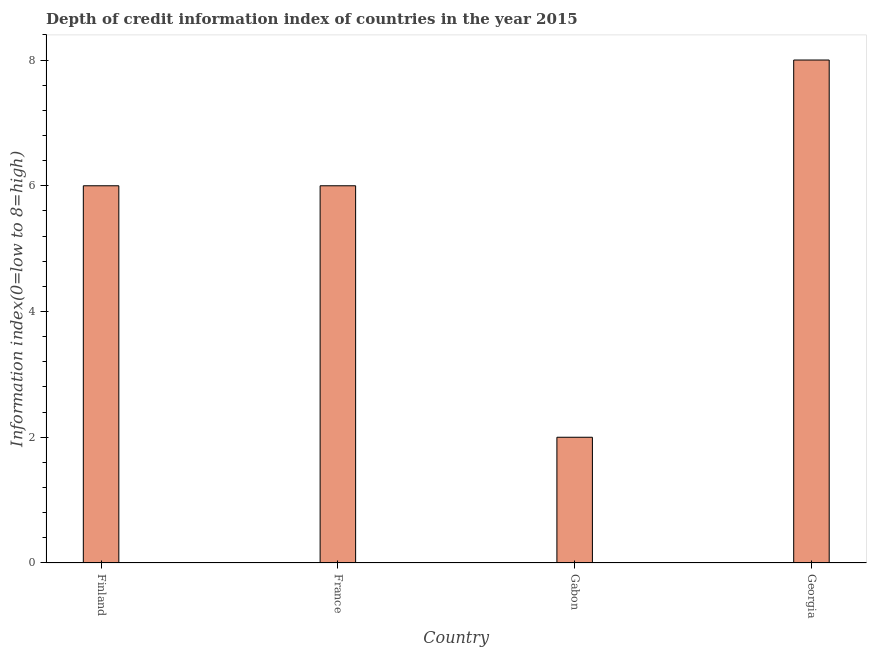Does the graph contain any zero values?
Make the answer very short. No. Does the graph contain grids?
Your answer should be very brief. No. What is the title of the graph?
Keep it short and to the point. Depth of credit information index of countries in the year 2015. What is the label or title of the Y-axis?
Make the answer very short. Information index(0=low to 8=high). What is the depth of credit information index in Finland?
Provide a succinct answer. 6. Across all countries, what is the maximum depth of credit information index?
Your answer should be compact. 8. Across all countries, what is the minimum depth of credit information index?
Ensure brevity in your answer.  2. In which country was the depth of credit information index maximum?
Keep it short and to the point. Georgia. In which country was the depth of credit information index minimum?
Provide a short and direct response. Gabon. What is the sum of the depth of credit information index?
Make the answer very short. 22. What is the average depth of credit information index per country?
Your response must be concise. 5.5. What is the median depth of credit information index?
Your response must be concise. 6. In how many countries, is the depth of credit information index greater than 3.2 ?
Keep it short and to the point. 3. What is the ratio of the depth of credit information index in France to that in Gabon?
Make the answer very short. 3. Is the depth of credit information index in Finland less than that in France?
Offer a terse response. No. Is the sum of the depth of credit information index in Finland and Gabon greater than the maximum depth of credit information index across all countries?
Your answer should be compact. No. In how many countries, is the depth of credit information index greater than the average depth of credit information index taken over all countries?
Offer a very short reply. 3. How many bars are there?
Offer a terse response. 4. Are all the bars in the graph horizontal?
Ensure brevity in your answer.  No. How many countries are there in the graph?
Offer a very short reply. 4. What is the difference between two consecutive major ticks on the Y-axis?
Make the answer very short. 2. Are the values on the major ticks of Y-axis written in scientific E-notation?
Your answer should be compact. No. What is the Information index(0=low to 8=high) in France?
Give a very brief answer. 6. What is the difference between the Information index(0=low to 8=high) in Finland and France?
Provide a succinct answer. 0. What is the difference between the Information index(0=low to 8=high) in Finland and Gabon?
Make the answer very short. 4. What is the difference between the Information index(0=low to 8=high) in Finland and Georgia?
Offer a very short reply. -2. What is the difference between the Information index(0=low to 8=high) in France and Georgia?
Keep it short and to the point. -2. What is the difference between the Information index(0=low to 8=high) in Gabon and Georgia?
Give a very brief answer. -6. What is the ratio of the Information index(0=low to 8=high) in Finland to that in Gabon?
Offer a very short reply. 3. What is the ratio of the Information index(0=low to 8=high) in France to that in Gabon?
Provide a short and direct response. 3. What is the ratio of the Information index(0=low to 8=high) in France to that in Georgia?
Your answer should be very brief. 0.75. 